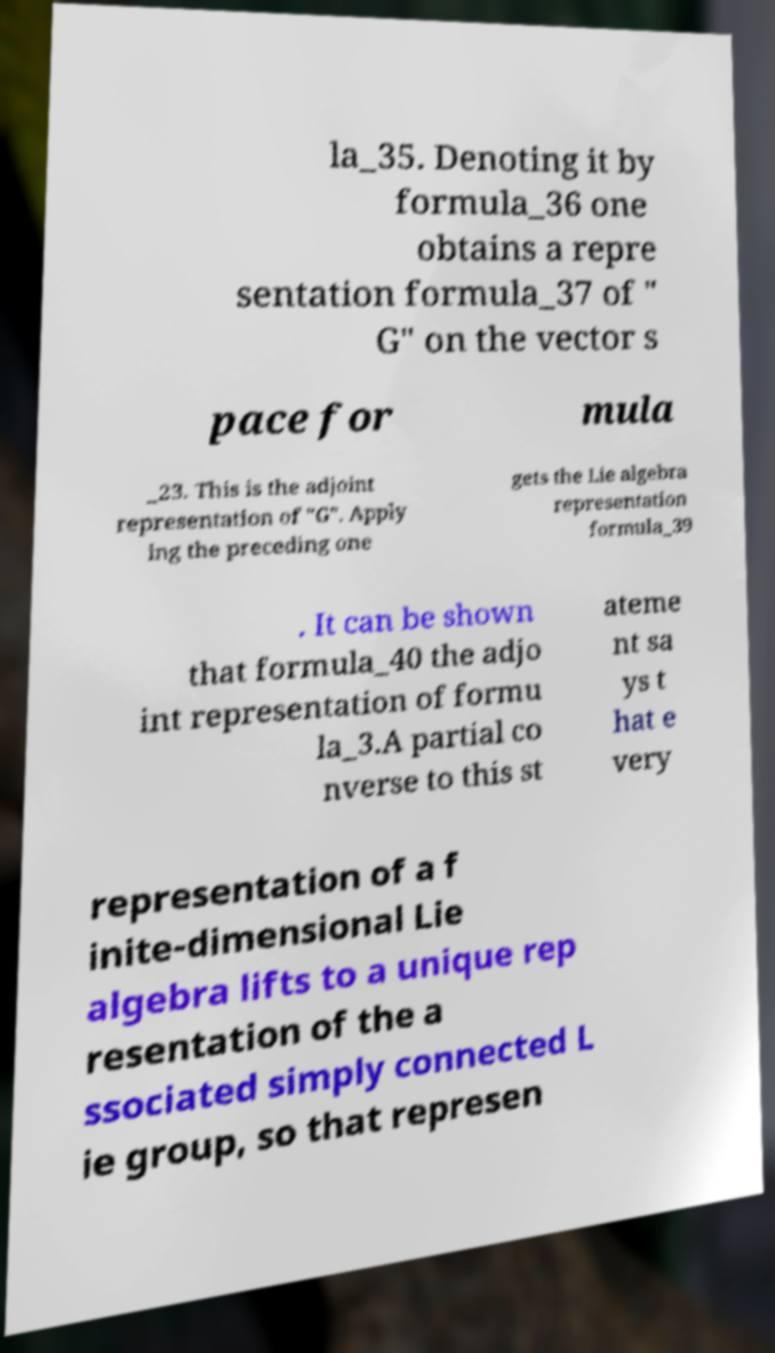Could you assist in decoding the text presented in this image and type it out clearly? la_35. Denoting it by formula_36 one obtains a repre sentation formula_37 of " G" on the vector s pace for mula _23. This is the adjoint representation of "G". Apply ing the preceding one gets the Lie algebra representation formula_39 . It can be shown that formula_40 the adjo int representation of formu la_3.A partial co nverse to this st ateme nt sa ys t hat e very representation of a f inite-dimensional Lie algebra lifts to a unique rep resentation of the a ssociated simply connected L ie group, so that represen 